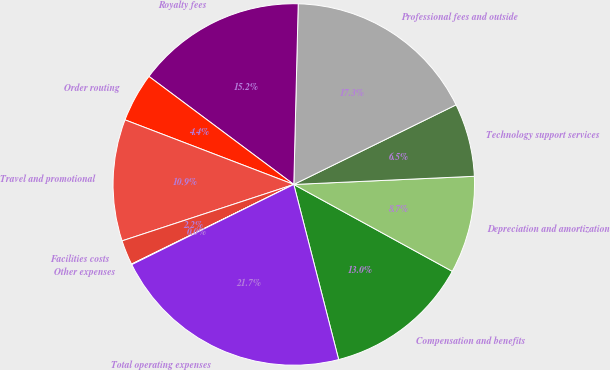<chart> <loc_0><loc_0><loc_500><loc_500><pie_chart><fcel>Compensation and benefits<fcel>Depreciation and amortization<fcel>Technology support services<fcel>Professional fees and outside<fcel>Royalty fees<fcel>Order routing<fcel>Travel and promotional<fcel>Facilities costs<fcel>Other expenses<fcel>Total operating expenses<nl><fcel>13.03%<fcel>8.7%<fcel>6.54%<fcel>17.35%<fcel>15.19%<fcel>4.38%<fcel>10.87%<fcel>2.21%<fcel>0.05%<fcel>21.68%<nl></chart> 